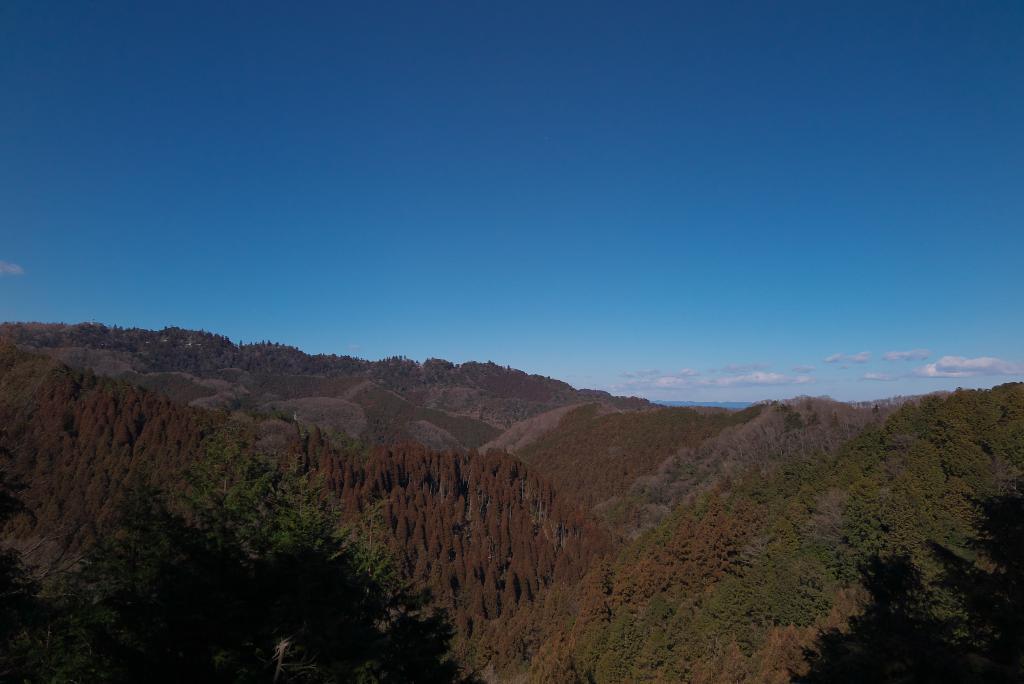Can you describe this image briefly? Here we can see trees,mountains and clouds in the sky. 